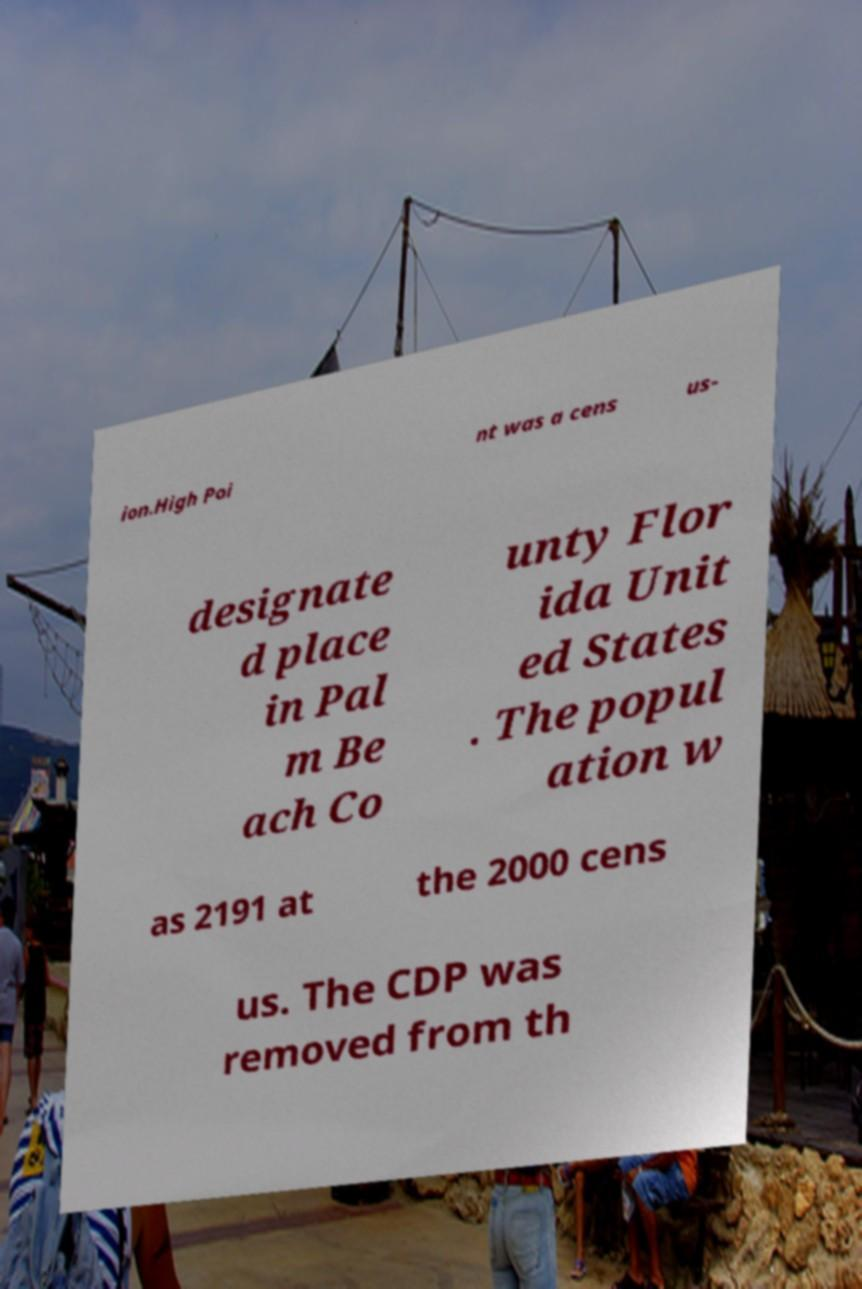For documentation purposes, I need the text within this image transcribed. Could you provide that? ion.High Poi nt was a cens us- designate d place in Pal m Be ach Co unty Flor ida Unit ed States . The popul ation w as 2191 at the 2000 cens us. The CDP was removed from th 